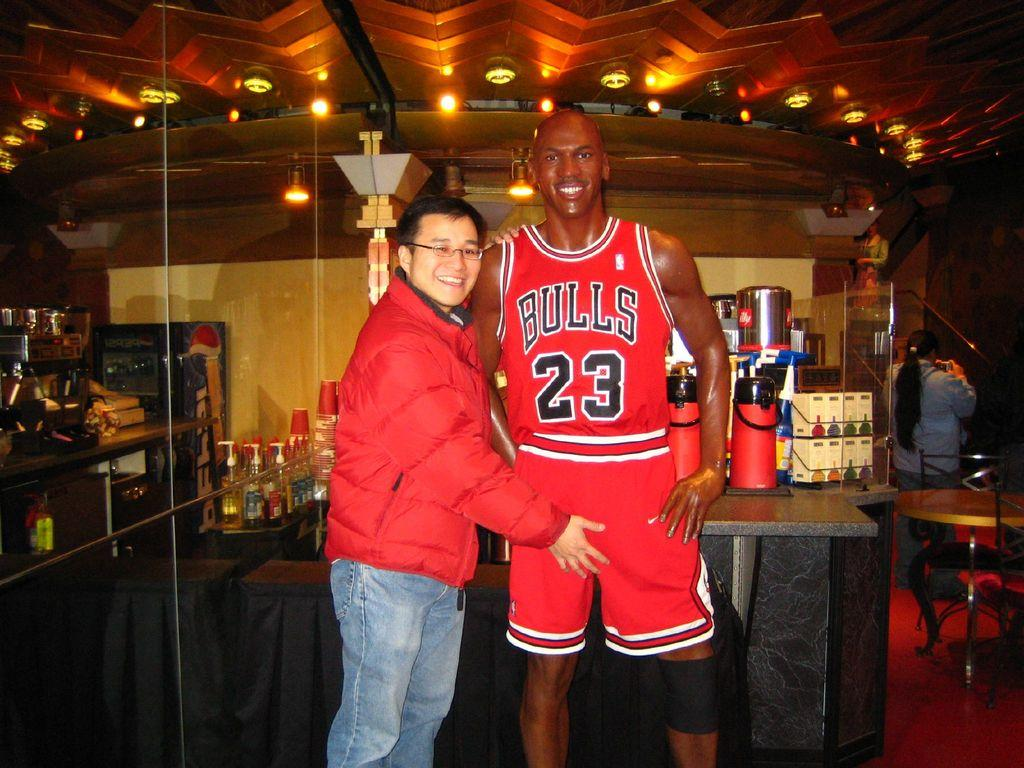<image>
Write a terse but informative summary of the picture. A fan has his hand on the crotch of a cardboard cutout figure of Bulls player number 23. 